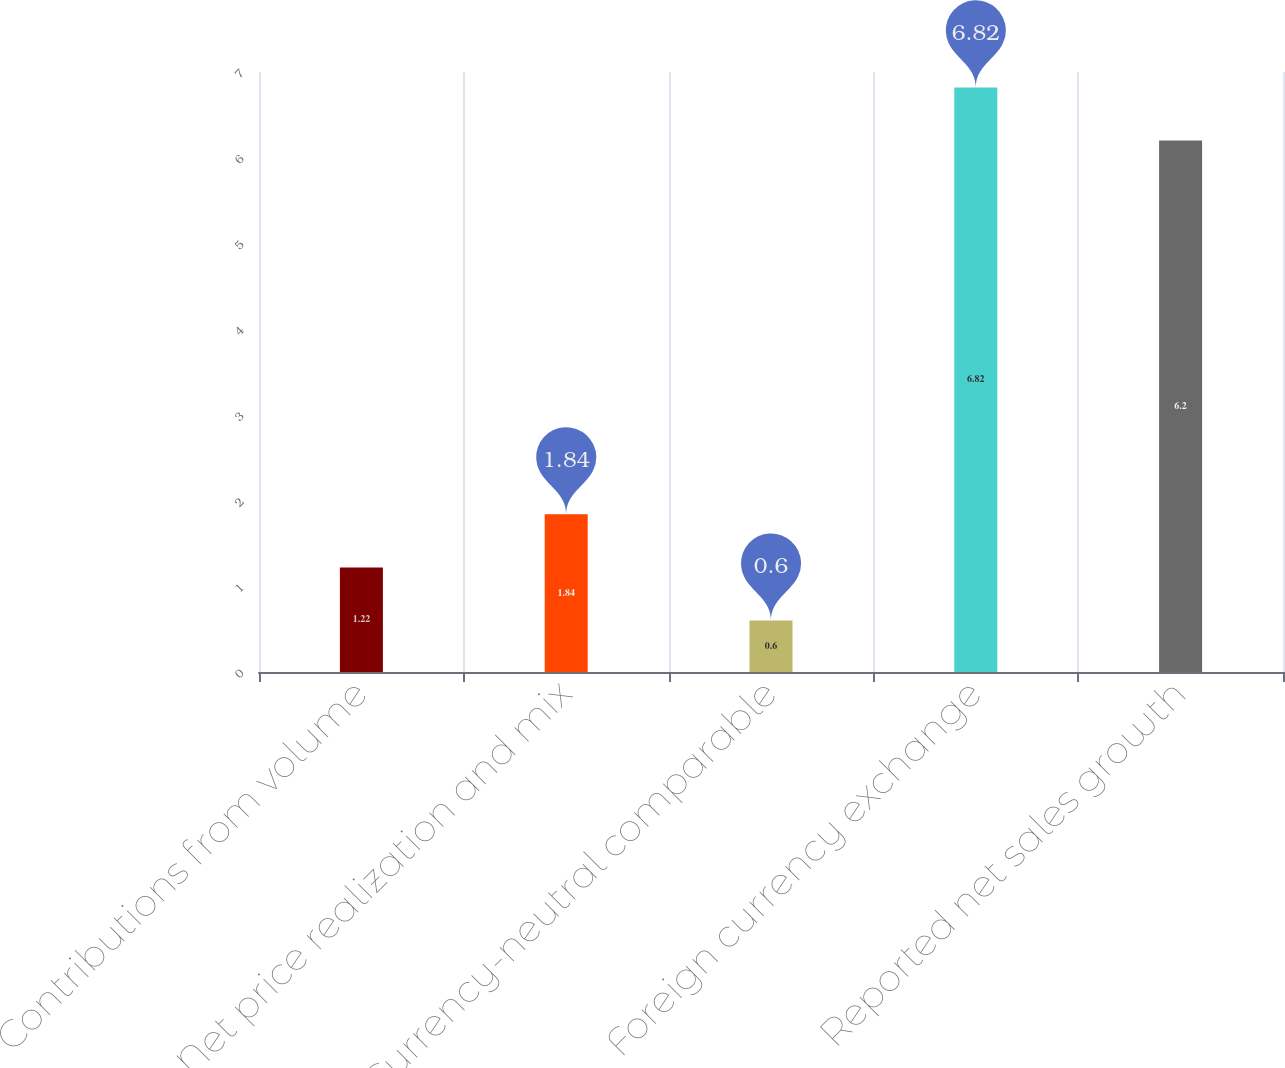Convert chart. <chart><loc_0><loc_0><loc_500><loc_500><bar_chart><fcel>Contributions from volume<fcel>Net price realization and mix<fcel>Currency-neutral comparable<fcel>Foreign currency exchange<fcel>Reported net sales growth<nl><fcel>1.22<fcel>1.84<fcel>0.6<fcel>6.82<fcel>6.2<nl></chart> 